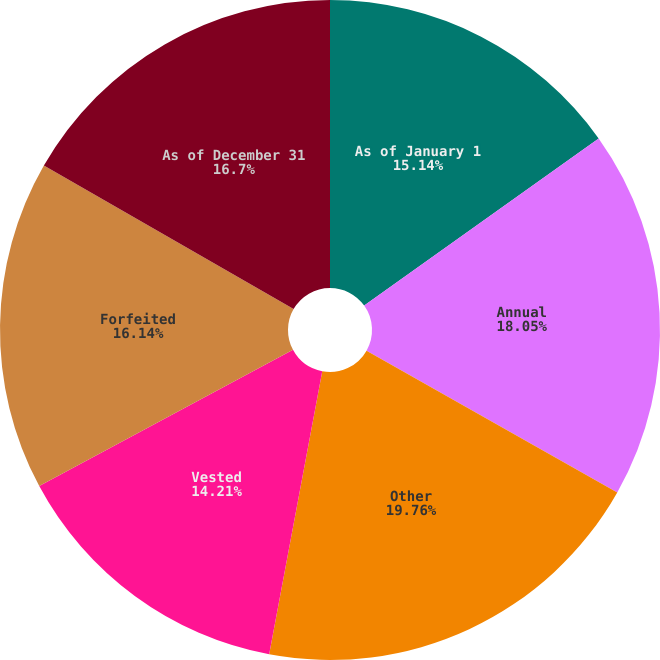Convert chart to OTSL. <chart><loc_0><loc_0><loc_500><loc_500><pie_chart><fcel>As of January 1<fcel>Annual<fcel>Other<fcel>Vested<fcel>Forfeited<fcel>As of December 31<nl><fcel>15.14%<fcel>18.05%<fcel>19.76%<fcel>14.21%<fcel>16.14%<fcel>16.7%<nl></chart> 